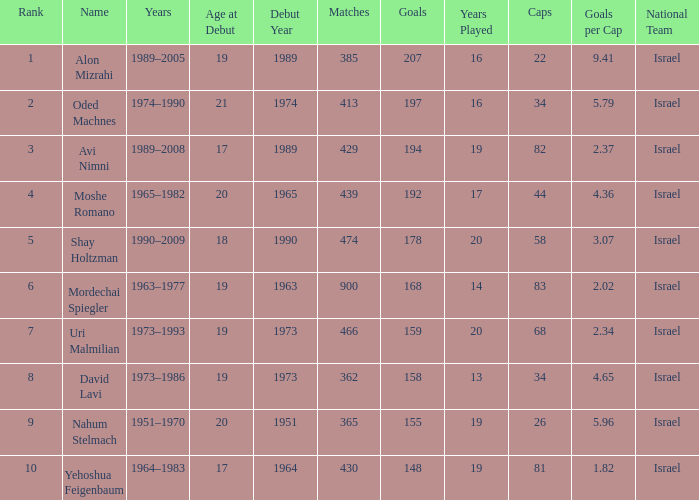What is the Rank of the player with 158 Goals in more than 362 Matches? 0.0. 